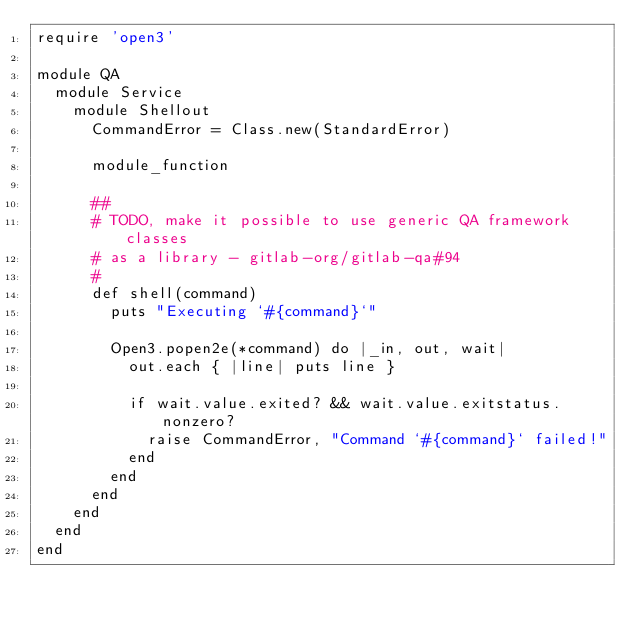Convert code to text. <code><loc_0><loc_0><loc_500><loc_500><_Ruby_>require 'open3'

module QA
  module Service
    module Shellout
      CommandError = Class.new(StandardError)

      module_function

      ##
      # TODO, make it possible to use generic QA framework classes
      # as a library - gitlab-org/gitlab-qa#94
      #
      def shell(command)
        puts "Executing `#{command}`"

        Open3.popen2e(*command) do |_in, out, wait|
          out.each { |line| puts line }

          if wait.value.exited? && wait.value.exitstatus.nonzero?
            raise CommandError, "Command `#{command}` failed!"
          end
        end
      end
    end
  end
end
</code> 